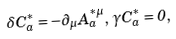Convert formula to latex. <formula><loc_0><loc_0><loc_500><loc_500>\delta C _ { a } ^ { * } = - \partial _ { \mu } A _ { a } ^ { * \mu } , \, \gamma C _ { a } ^ { * } = 0 ,</formula> 